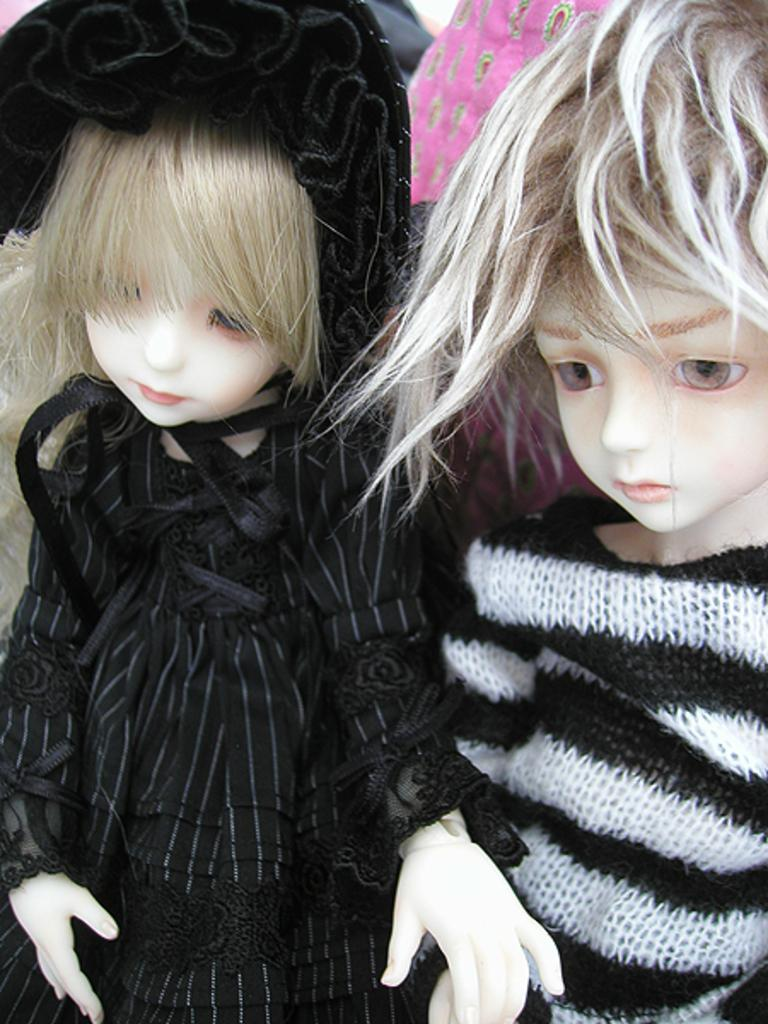How many dolls are present in the image? There are two dolls in the image. What colors are the dolls? The dolls are in black and white color. What colors can be seen in the background of the image? The background of the image is pink and grey. Can you tell me how many cans of paint are visible in the image? There are no cans of paint present in the image; it features two black and white dolls against a pink and grey background. Are there any parent figures visible in the image? There is no mention of parent figures in the provided facts, and none are visible in the image. 